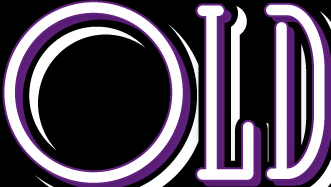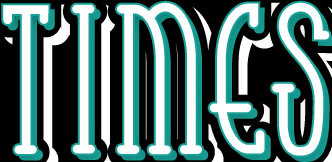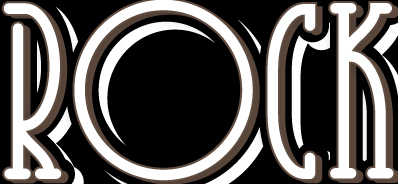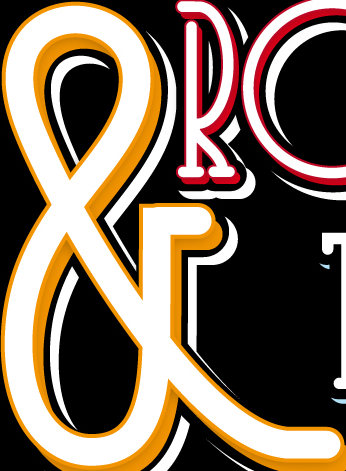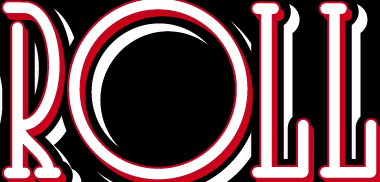What words are shown in these images in order, separated by a semicolon? OLD; TIMES; ROCK; &; ROLL 